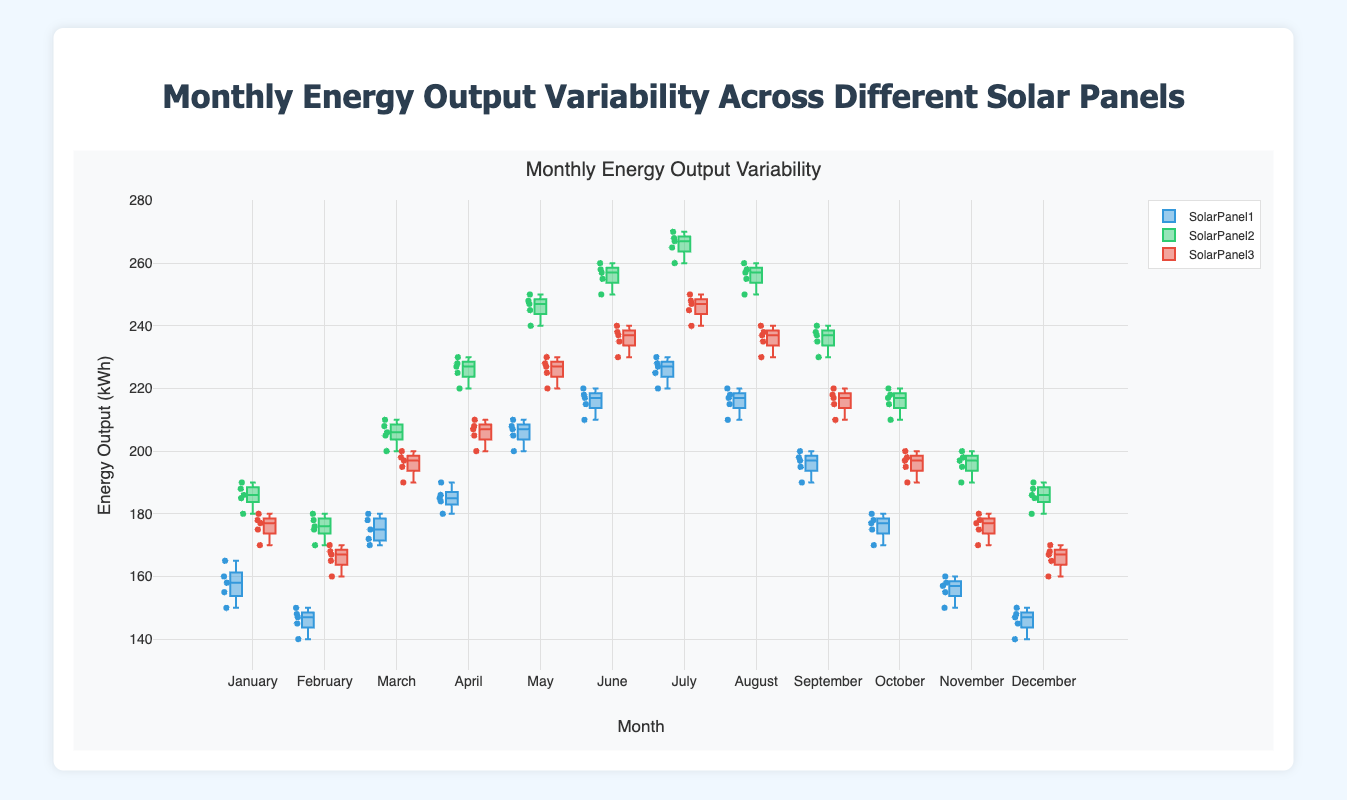What's the overall trend in energy output across the months? By examining the x-axis denoting the months and the y-axis showing the energy output, we can observe that all solar panels generally have an increasing trend in energy output from January to July, followed by a decreasing trend from August to December.
Answer: Increasing from January to July, decreasing from August to December Which month shows the highest variability in energy output for SolarPanel1? By reviewing the spread of the box plots for SolarPanel1 across months, we can see that July has the largest interquartile range and the most widely scattered points, indicating the highest variability.
Answer: July Which solar panel consistently generates the most energy output throughout the year? By comparing the medians of the box plots across different months, SolarPanel2 consistently has higher median values compared to SolarPanel1 and SolarPanel3, indicating it generates the most energy output throughout the year.
Answer: SolarPanel2 Is there any month where all three solar panels have similar energy outputs? Looking at the medians and spread of the box plots for all three solar panels, we can observe that in March and November, the boxes and medians are relatively close to each other.
Answer: March and November Which solar panel has the highest median output in May? Examining the median lines within the box plots for May, SolarPanel2 has the highest median value.
Answer: SolarPanel2 In which month does SolarPanel3 exhibit the least variability? We need to examine which month has the smallest spread within the box plot for SolarPanel3. February shows the smallest interquartile range and smallest spread of points.
Answer: February Are there any months where the maximum energy output observed for SolarPanel1 is less than the minimum energy output observed for SolarPanel2? By identifying the maximum of SolarPanel1 and the minimum of SolarPanel2 for each month, in May, June, July, and August, the maximum output of SolarPanel1 is less than the minimum output of SolarPanel2.
Answer: May, June, July, and August Which panel shows the most variation in energy output during the peak summer month of July? By comparing the spread and interquartile ranges of the box plots in July, SolarPanel3 has the widest spread and highest variation in energy output.
Answer: SolarPanel3 What's the median energy output of SolarPanel1 in December? The median can be found as the middle value of the sorted December outputs for SolarPanel1: [140, 145, 147, 148, 150]. The median is the middle value, 147.
Answer: 147 Do any of the solar panels have outliers displayed in their box plots, and if so, which ones? By examining the individual points beyond the whiskers of the box plots, no outliers are indicated for any of the solar panels in the given data.
Answer: No outliers 